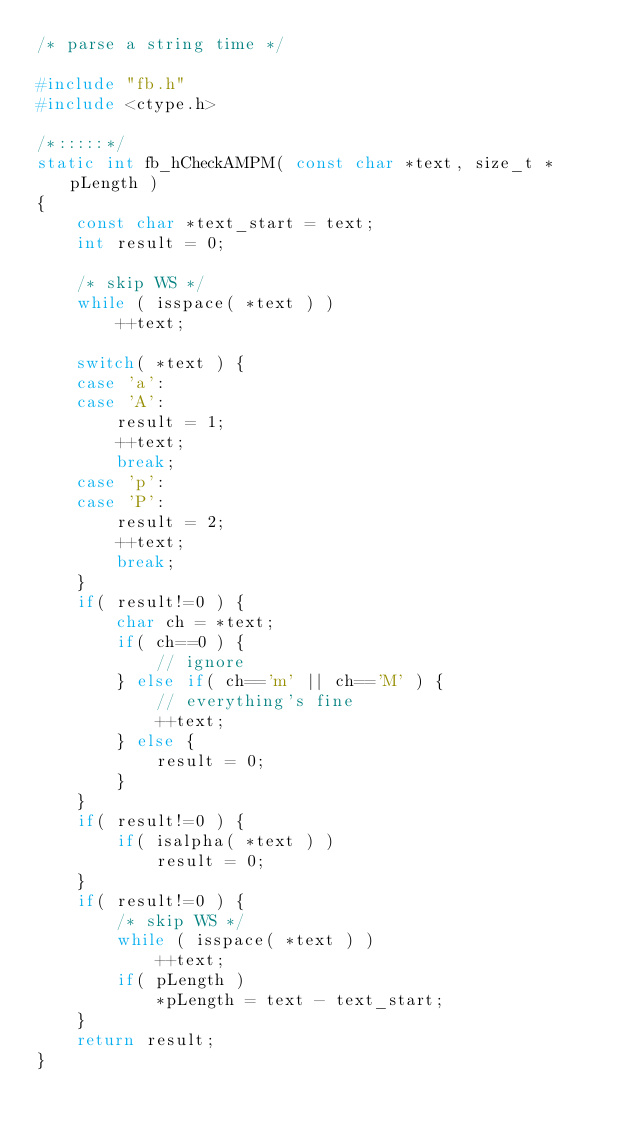<code> <loc_0><loc_0><loc_500><loc_500><_C_>/* parse a string time */

#include "fb.h"
#include <ctype.h>

/*:::::*/
static int fb_hCheckAMPM( const char *text, size_t *pLength )
{
    const char *text_start = text;
    int result = 0;

    /* skip WS */
    while ( isspace( *text ) )
        ++text;

    switch( *text ) {
    case 'a':
    case 'A':
        result = 1;
        ++text;
        break;
    case 'p':
    case 'P':
        result = 2;
        ++text;
        break;
    }
    if( result!=0 ) {
        char ch = *text;
        if( ch==0 ) {
            // ignore
        } else if( ch=='m' || ch=='M' ) {
            // everything's fine
            ++text;
        } else {
            result = 0;
        }
    }
    if( result!=0 ) {
        if( isalpha( *text ) )
            result = 0;
    }
    if( result!=0 ) {
        /* skip WS */
        while ( isspace( *text ) )
            ++text;
        if( pLength )
            *pLength = text - text_start;
    }
    return result;
}
</code> 